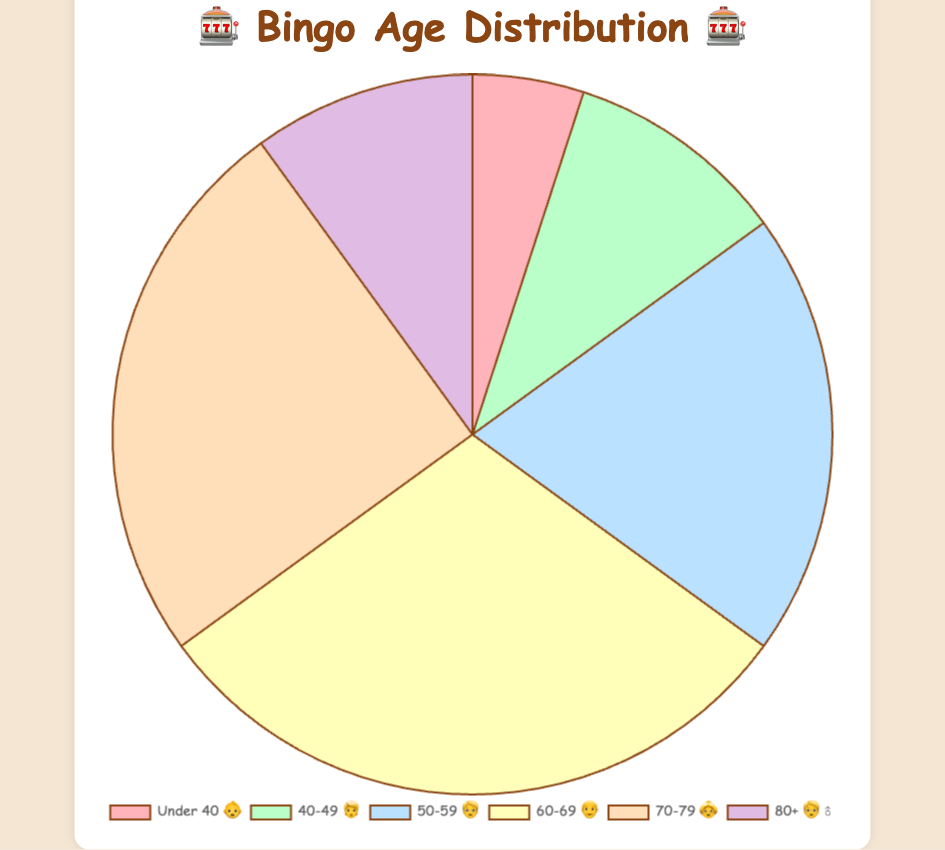What age group has the highest percentage of Bingo players? The age group '60-69 👴' has the highest percentage. By looking at the chart, it's clear that this group occupies the largest portion of the pie.
Answer: 60-69 👴 Which two age groups combined make up half of the overall Bingo player population? Adding the percentages of the '60-69 👴' and '70-79 👵' groups (30% and 25%, respectively) gives us 55%, which is just over half.
Answer: 60-69 👴 and 70-79 👵 What's the total percentage for players aged 50 and above? Adding the percentages for '50-59 🧓', '60-69 👴', '70-79 👵', and '80+ 🧓‍♂️' results in 20% + 30% + 25% + 10% = 85%.
Answer: 85% What is the smallest age demographic for Bingo players? The age group 'Under 40 👶' has the smallest slice of the pie chart, indicating it's the least represented group.
Answer: Under 40 👶 Which age group has an equal percentage to the '40-49 🧑' group? The percentage for '40-49 🧑' is 10%, which is also the percentage for the '80+ 🧓‍♂️' group.
Answer: 80+ 🧓‍♂️ What's the difference in the percentage between the '50-59 🧓' and 'Under 40 👶' age groups? The '50-59 🧓' group has a 20% percentage and the 'Under 40 👶' group has a 5% percentage. The difference is 20% - 5% = 15%.
Answer: 15% What is the average percentage of all age groups in the chart? The average percentage is calculated by adding all percentages (5% + 10% + 20% + 30% + 25% + 10% = 100%) and then dividing by the number of groups (6). So, 100% / 6 = approximately 16.67%.
Answer: ~16.67% How many age groups have a percentage greater than or equal to 20%? The age groups are '50-59 🧓' (20%), '60-69 👴' (30%), and '70-79 👵' (25%). There are 3 such groups.
Answer: 3 Which age group sees twice the percentage compared to the '40-49 🧑' group? The '50-59 🧓' group has 20%, which is twice the 10% of the '40-49 🧑' group.
Answer: 50-59 🧓 What is the combined percentage of all age groups below 60? Adding the percentages for 'Under 40 👶', '40-49 🧑', and '50-59 🧓' results in 5% + 10% + 20% = 35%.
Answer: 35% 